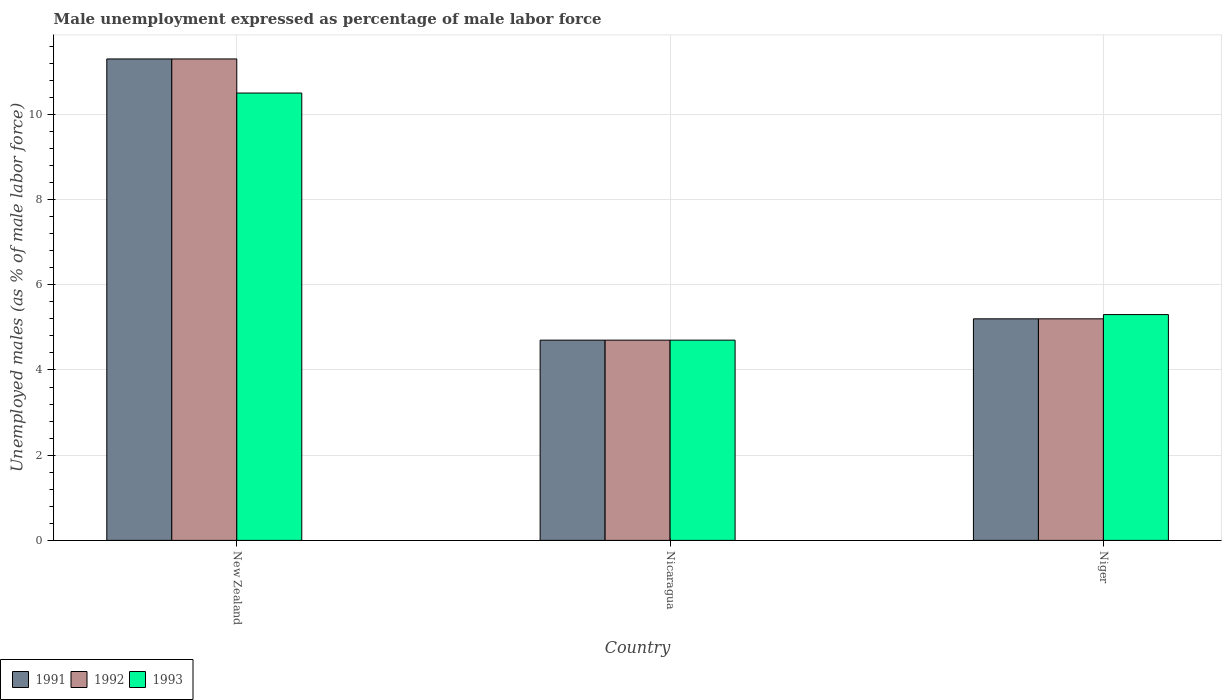How many groups of bars are there?
Provide a succinct answer. 3. How many bars are there on the 2nd tick from the left?
Provide a short and direct response. 3. What is the label of the 2nd group of bars from the left?
Give a very brief answer. Nicaragua. In how many cases, is the number of bars for a given country not equal to the number of legend labels?
Offer a terse response. 0. What is the unemployment in males in in 1993 in Nicaragua?
Offer a very short reply. 4.7. Across all countries, what is the maximum unemployment in males in in 1992?
Your answer should be compact. 11.3. Across all countries, what is the minimum unemployment in males in in 1993?
Offer a terse response. 4.7. In which country was the unemployment in males in in 1993 maximum?
Offer a terse response. New Zealand. In which country was the unemployment in males in in 1992 minimum?
Provide a short and direct response. Nicaragua. What is the difference between the unemployment in males in in 1991 in New Zealand and that in Nicaragua?
Ensure brevity in your answer.  6.6. What is the difference between the unemployment in males in in 1992 in Niger and the unemployment in males in in 1993 in New Zealand?
Your answer should be very brief. -5.3. What is the average unemployment in males in in 1991 per country?
Provide a short and direct response. 7.07. What is the difference between the unemployment in males in of/in 1992 and unemployment in males in of/in 1993 in Niger?
Ensure brevity in your answer.  -0.1. What is the ratio of the unemployment in males in in 1993 in New Zealand to that in Nicaragua?
Give a very brief answer. 2.23. Is the unemployment in males in in 1993 in New Zealand less than that in Nicaragua?
Your answer should be compact. No. What is the difference between the highest and the second highest unemployment in males in in 1993?
Your answer should be very brief. 5.8. What is the difference between the highest and the lowest unemployment in males in in 1991?
Offer a terse response. 6.6. In how many countries, is the unemployment in males in in 1992 greater than the average unemployment in males in in 1992 taken over all countries?
Offer a very short reply. 1. Is the sum of the unemployment in males in in 1993 in New Zealand and Niger greater than the maximum unemployment in males in in 1991 across all countries?
Provide a short and direct response. Yes. What does the 1st bar from the right in Niger represents?
Provide a short and direct response. 1993. What is the difference between two consecutive major ticks on the Y-axis?
Ensure brevity in your answer.  2. Are the values on the major ticks of Y-axis written in scientific E-notation?
Your answer should be very brief. No. Does the graph contain any zero values?
Your answer should be compact. No. Does the graph contain grids?
Your response must be concise. Yes. What is the title of the graph?
Keep it short and to the point. Male unemployment expressed as percentage of male labor force. Does "2014" appear as one of the legend labels in the graph?
Provide a short and direct response. No. What is the label or title of the X-axis?
Provide a short and direct response. Country. What is the label or title of the Y-axis?
Your answer should be very brief. Unemployed males (as % of male labor force). What is the Unemployed males (as % of male labor force) of 1991 in New Zealand?
Your answer should be very brief. 11.3. What is the Unemployed males (as % of male labor force) of 1992 in New Zealand?
Keep it short and to the point. 11.3. What is the Unemployed males (as % of male labor force) of 1993 in New Zealand?
Keep it short and to the point. 10.5. What is the Unemployed males (as % of male labor force) of 1991 in Nicaragua?
Provide a short and direct response. 4.7. What is the Unemployed males (as % of male labor force) in 1992 in Nicaragua?
Give a very brief answer. 4.7. What is the Unemployed males (as % of male labor force) of 1993 in Nicaragua?
Make the answer very short. 4.7. What is the Unemployed males (as % of male labor force) in 1991 in Niger?
Offer a very short reply. 5.2. What is the Unemployed males (as % of male labor force) of 1992 in Niger?
Ensure brevity in your answer.  5.2. What is the Unemployed males (as % of male labor force) of 1993 in Niger?
Provide a succinct answer. 5.3. Across all countries, what is the maximum Unemployed males (as % of male labor force) in 1991?
Your response must be concise. 11.3. Across all countries, what is the maximum Unemployed males (as % of male labor force) of 1992?
Make the answer very short. 11.3. Across all countries, what is the maximum Unemployed males (as % of male labor force) of 1993?
Provide a short and direct response. 10.5. Across all countries, what is the minimum Unemployed males (as % of male labor force) of 1991?
Your answer should be compact. 4.7. Across all countries, what is the minimum Unemployed males (as % of male labor force) of 1992?
Your answer should be very brief. 4.7. Across all countries, what is the minimum Unemployed males (as % of male labor force) in 1993?
Provide a short and direct response. 4.7. What is the total Unemployed males (as % of male labor force) in 1991 in the graph?
Your answer should be compact. 21.2. What is the total Unemployed males (as % of male labor force) in 1992 in the graph?
Your answer should be compact. 21.2. What is the difference between the Unemployed males (as % of male labor force) of 1992 in New Zealand and that in Nicaragua?
Your answer should be very brief. 6.6. What is the difference between the Unemployed males (as % of male labor force) in 1991 in New Zealand and that in Niger?
Your answer should be compact. 6.1. What is the difference between the Unemployed males (as % of male labor force) in 1992 in New Zealand and that in Niger?
Provide a short and direct response. 6.1. What is the difference between the Unemployed males (as % of male labor force) of 1993 in New Zealand and that in Niger?
Ensure brevity in your answer.  5.2. What is the difference between the Unemployed males (as % of male labor force) in 1992 in Nicaragua and that in Niger?
Your answer should be very brief. -0.5. What is the difference between the Unemployed males (as % of male labor force) of 1991 in New Zealand and the Unemployed males (as % of male labor force) of 1993 in Nicaragua?
Offer a terse response. 6.6. What is the difference between the Unemployed males (as % of male labor force) of 1992 in New Zealand and the Unemployed males (as % of male labor force) of 1993 in Nicaragua?
Your answer should be compact. 6.6. What is the difference between the Unemployed males (as % of male labor force) of 1991 in Nicaragua and the Unemployed males (as % of male labor force) of 1993 in Niger?
Offer a terse response. -0.6. What is the average Unemployed males (as % of male labor force) in 1991 per country?
Keep it short and to the point. 7.07. What is the average Unemployed males (as % of male labor force) in 1992 per country?
Provide a succinct answer. 7.07. What is the average Unemployed males (as % of male labor force) of 1993 per country?
Keep it short and to the point. 6.83. What is the difference between the Unemployed males (as % of male labor force) of 1991 and Unemployed males (as % of male labor force) of 1992 in Nicaragua?
Your answer should be compact. 0. What is the difference between the Unemployed males (as % of male labor force) of 1991 and Unemployed males (as % of male labor force) of 1993 in Nicaragua?
Keep it short and to the point. 0. What is the difference between the Unemployed males (as % of male labor force) of 1992 and Unemployed males (as % of male labor force) of 1993 in Nicaragua?
Keep it short and to the point. 0. What is the ratio of the Unemployed males (as % of male labor force) in 1991 in New Zealand to that in Nicaragua?
Keep it short and to the point. 2.4. What is the ratio of the Unemployed males (as % of male labor force) of 1992 in New Zealand to that in Nicaragua?
Your response must be concise. 2.4. What is the ratio of the Unemployed males (as % of male labor force) of 1993 in New Zealand to that in Nicaragua?
Your answer should be very brief. 2.23. What is the ratio of the Unemployed males (as % of male labor force) in 1991 in New Zealand to that in Niger?
Make the answer very short. 2.17. What is the ratio of the Unemployed males (as % of male labor force) of 1992 in New Zealand to that in Niger?
Offer a very short reply. 2.17. What is the ratio of the Unemployed males (as % of male labor force) of 1993 in New Zealand to that in Niger?
Offer a very short reply. 1.98. What is the ratio of the Unemployed males (as % of male labor force) in 1991 in Nicaragua to that in Niger?
Give a very brief answer. 0.9. What is the ratio of the Unemployed males (as % of male labor force) of 1992 in Nicaragua to that in Niger?
Offer a terse response. 0.9. What is the ratio of the Unemployed males (as % of male labor force) of 1993 in Nicaragua to that in Niger?
Your answer should be very brief. 0.89. What is the difference between the highest and the second highest Unemployed males (as % of male labor force) in 1991?
Make the answer very short. 6.1. What is the difference between the highest and the lowest Unemployed males (as % of male labor force) of 1991?
Offer a very short reply. 6.6. 